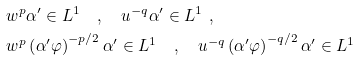<formula> <loc_0><loc_0><loc_500><loc_500>& w ^ { p } \alpha ^ { \prime } \in L ^ { 1 } \quad , \quad u ^ { - q } \alpha ^ { \prime } \in L ^ { 1 } \ , \\ & w ^ { p } \left ( \alpha ^ { \prime } \varphi \right ) ^ { - p / 2 } \alpha ^ { \prime } \in L ^ { 1 } \quad , \quad u ^ { - q } \left ( \alpha ^ { \prime } \varphi \right ) ^ { - q / 2 } \alpha ^ { \prime } \in L ^ { 1 }</formula> 